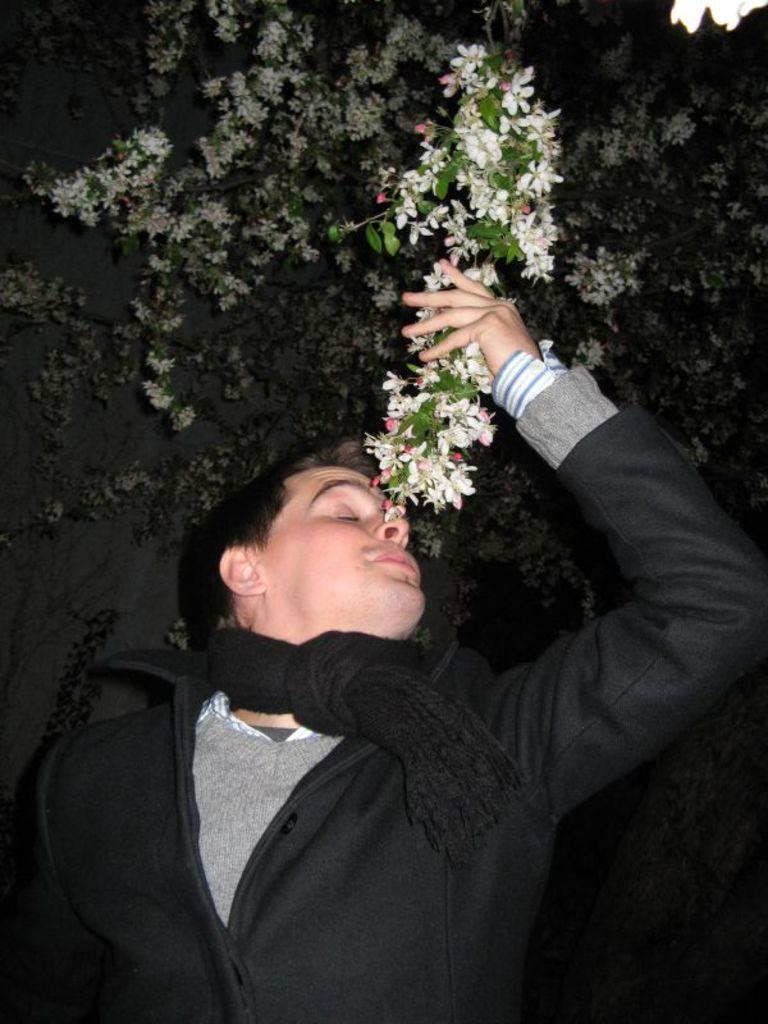What is the main subject of the image? There is a man standing in the image. What can be observed about the man's attire? The man is wearing clothes. What type of natural elements are present in the image? Tiny flowers and leaves are visible in the image. What type of vegetable is being sliced on a loaf in the image? There is no vegetable or loaf present in the image; it features a man standing and natural elements like tiny flowers and leaves. 